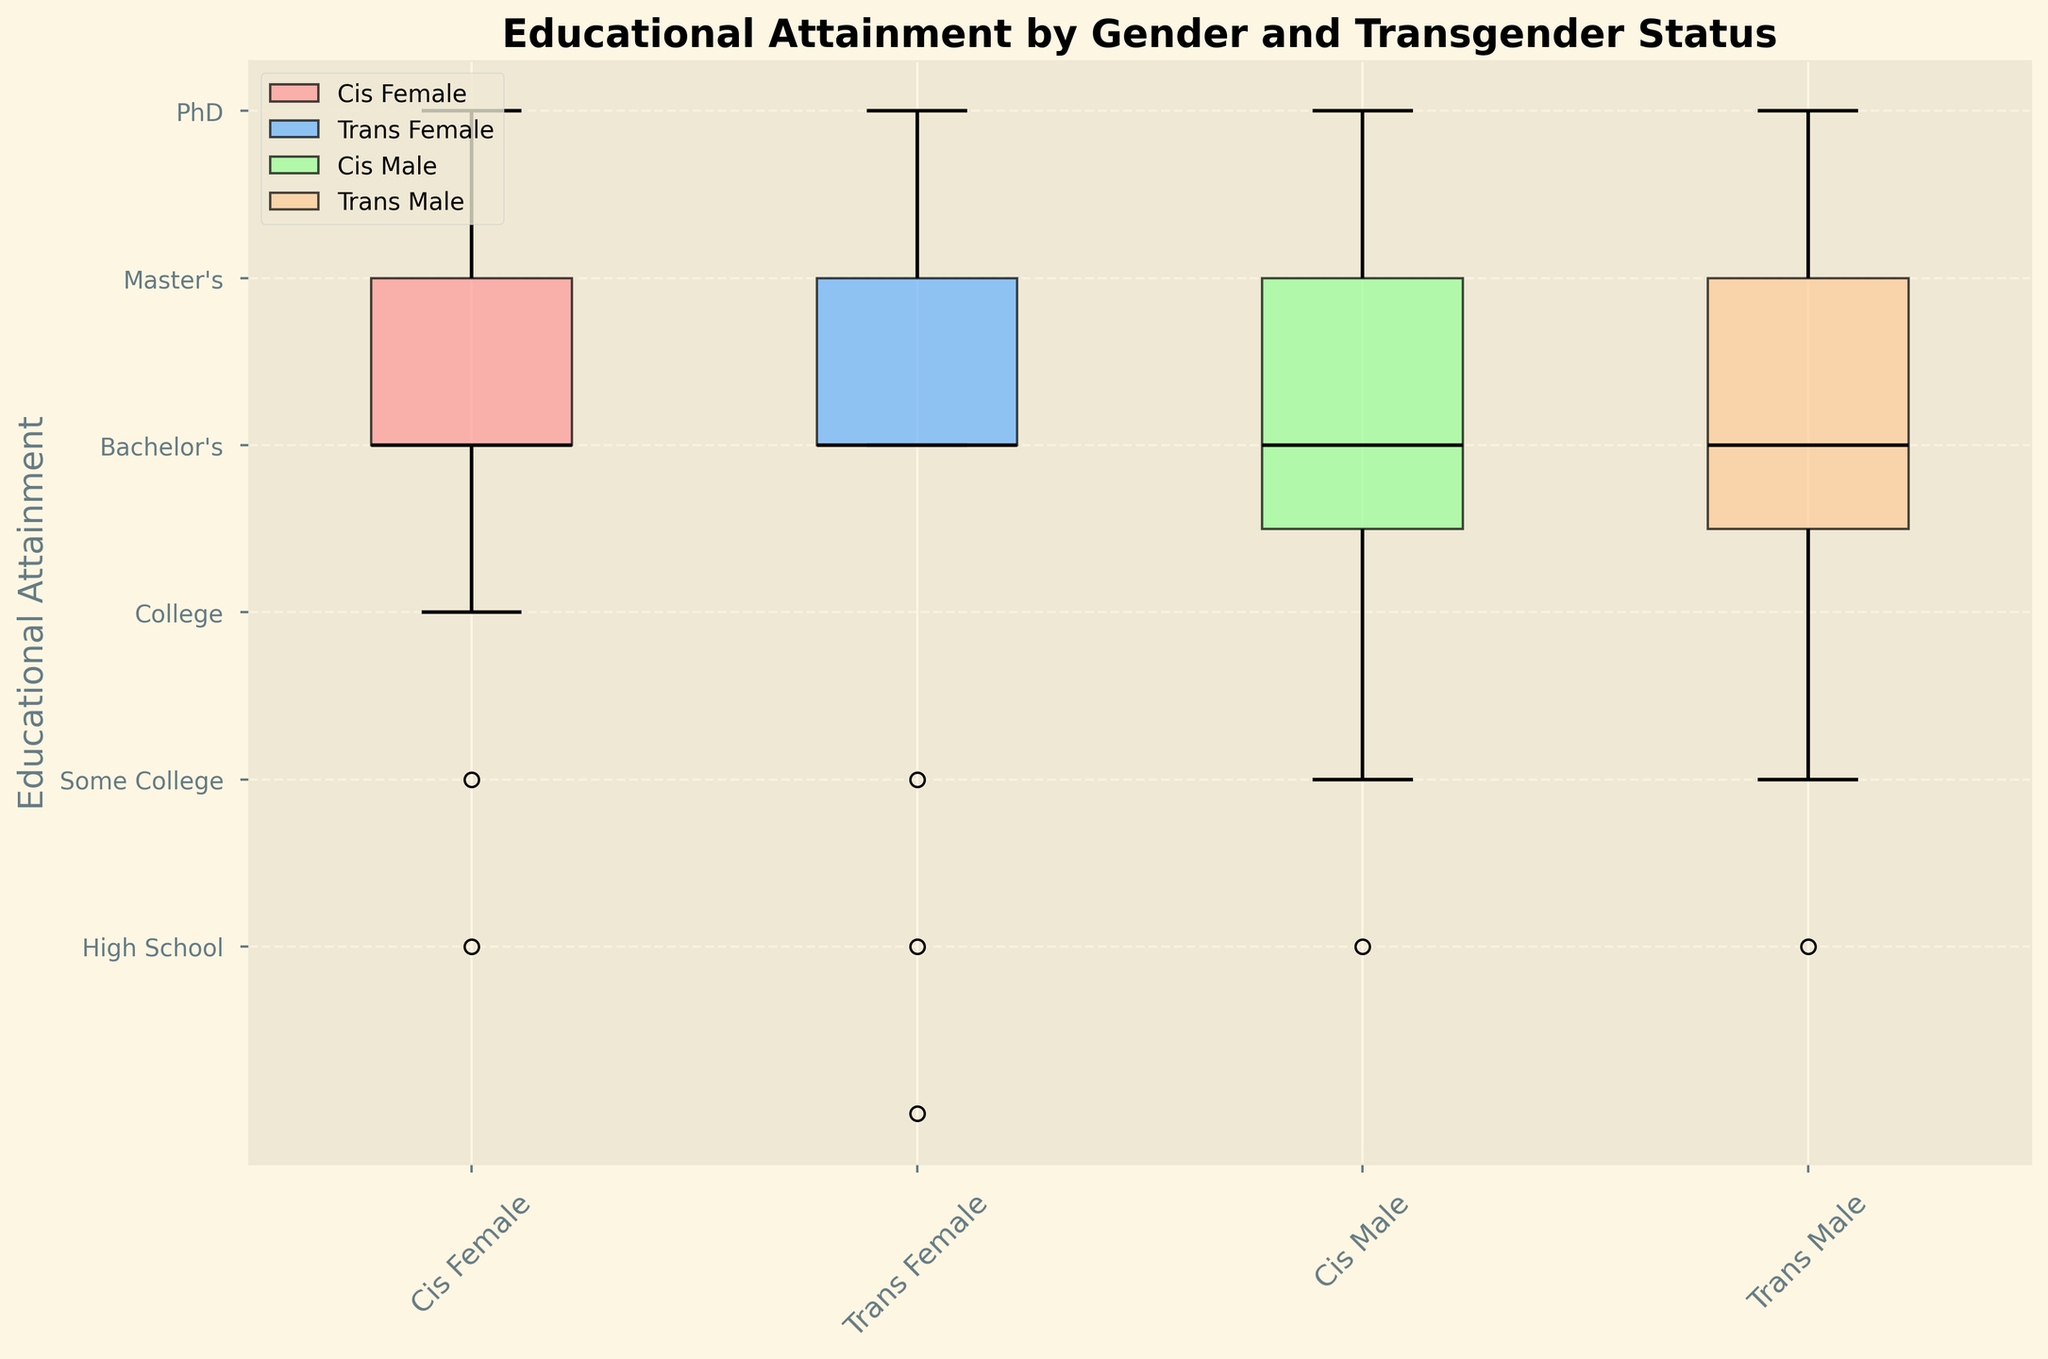what is the title of the figure? Look at the top of the figure, where the title is located.
Answer: Educational Attainment by Gender and Transgender Status What are the four groups shown on the x-axis? The x-axis labels are presented at the bottom of the figure, showing the different groups being compared.
Answer: Cis Female, Trans Female, Cis Male, Trans Male Which group has the highest median educational attainment? Compare the dark lines (medians) in the middle of the boxes for each group. The highest median line shows the group with the highest median educational attainment.
Answer: Cis Female How many different educational attainment levels are compared in the figure? The y-axis lists the distinct educational attainment categories, each with its own label. Count these labels.
Answer: Six Which group has the widest range of educational attainment levels? Identify the width of the boxes and whiskers, indicating the range from the lowest to the highest educational attainment within each group.
Answer: Trans Female Between Cis Male and Trans Male, which group has a higher maximum educational level? The top whisker (or top of the box if there is no whisker) indicates the maximum educational level for each group. Compare these for Cis Male and Trans Male.
Answer: Cis Male What position does "Master's" hold in the y-axis labels? Look at the y-axis labels and count the position of "Master's," starting from the bottom.
Answer: Fifth Which group's median educational level is a Bachelor's and also has some participants with a PhD level? Look at the dark median lines to find the Bachelor's level in the y-axis and the ending of the top whisker if it reaches PhD level for a group.
Answer: Trans Male Who has a broader distribution, Cis Female or Cis Male? Check the length from the bottom whisker to the top whisker in Cis Female and Cis Male to determine which group has a broader distribution.
Answer: Cis Female Is there any group where the median value falls at the top educational level (PhD)? Check for groups where the dark median line aligns with the PhD level on the y-axis.
Answer: No 